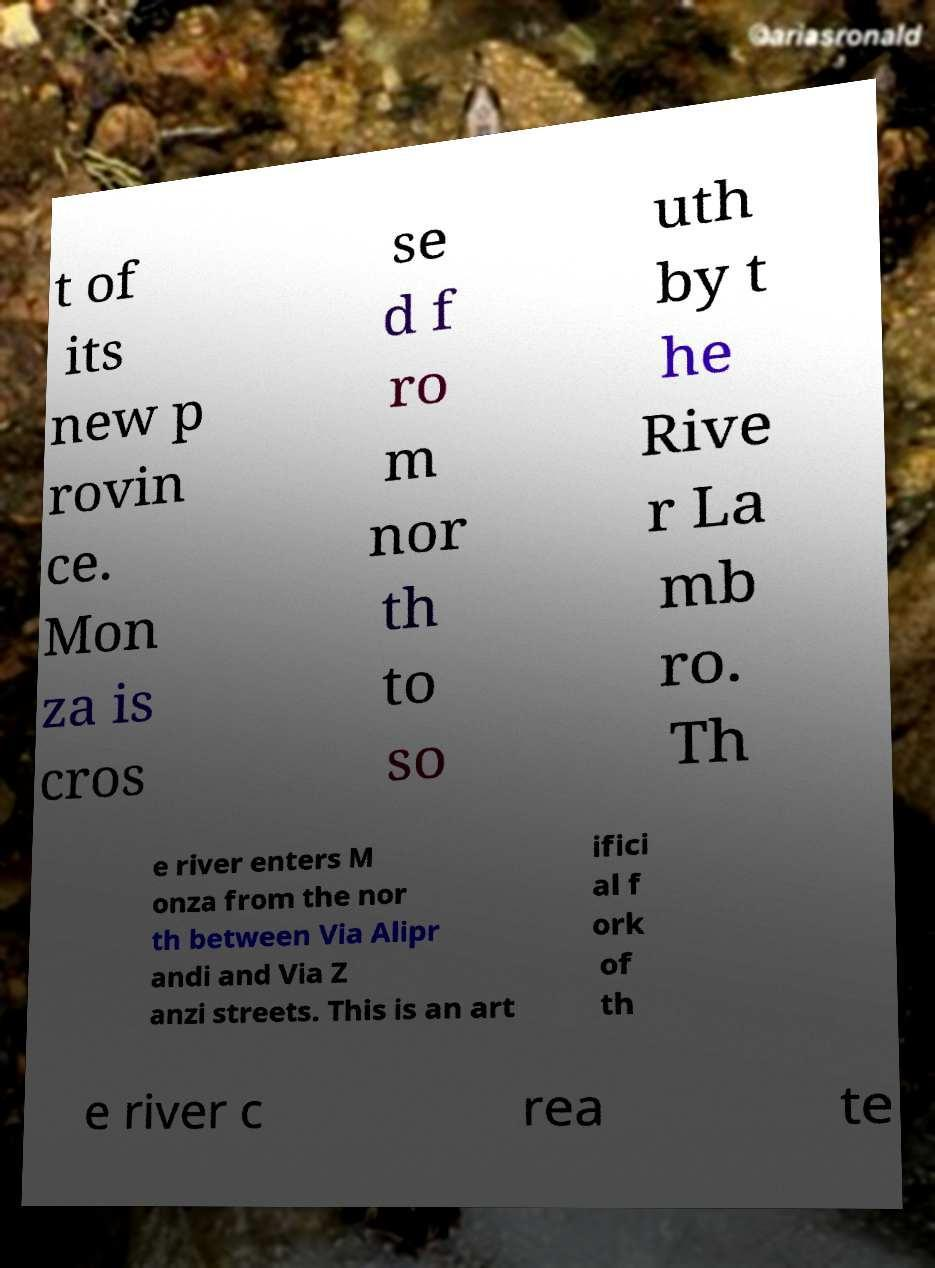There's text embedded in this image that I need extracted. Can you transcribe it verbatim? t of its new p rovin ce. Mon za is cros se d f ro m nor th to so uth by t he Rive r La mb ro. Th e river enters M onza from the nor th between Via Alipr andi and Via Z anzi streets. This is an art ifici al f ork of th e river c rea te 